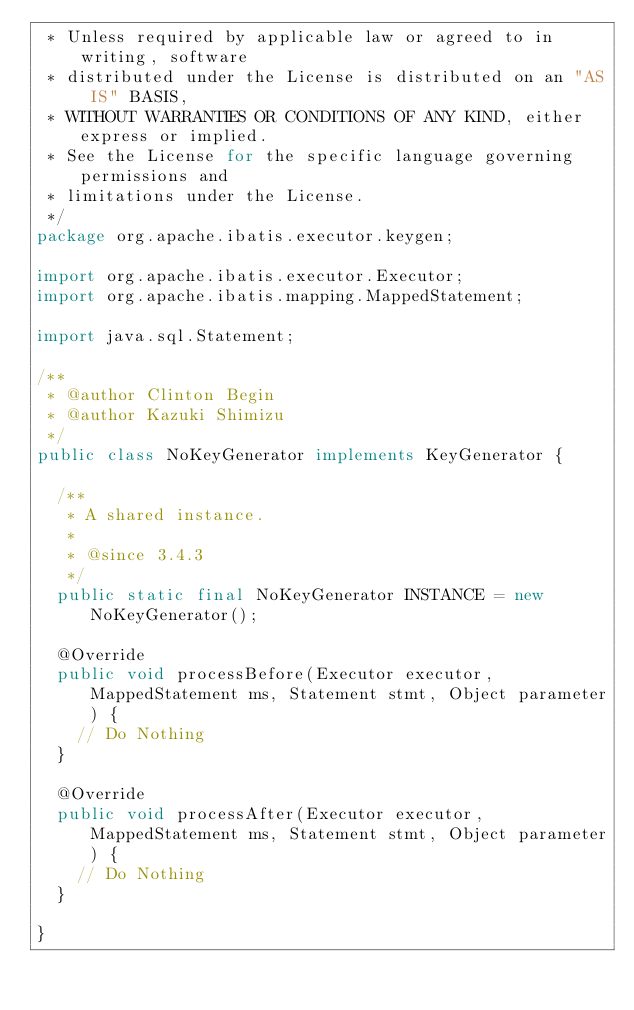<code> <loc_0><loc_0><loc_500><loc_500><_Java_> * Unless required by applicable law or agreed to in writing, software
 * distributed under the License is distributed on an "AS IS" BASIS,
 * WITHOUT WARRANTIES OR CONDITIONS OF ANY KIND, either express or implied.
 * See the License for the specific language governing permissions and
 * limitations under the License.
 */
package org.apache.ibatis.executor.keygen;

import org.apache.ibatis.executor.Executor;
import org.apache.ibatis.mapping.MappedStatement;

import java.sql.Statement;

/**
 * @author Clinton Begin
 * @author Kazuki Shimizu
 */
public class NoKeyGenerator implements KeyGenerator {

  /**
   * A shared instance.
   *
   * @since 3.4.3
   */
  public static final NoKeyGenerator INSTANCE = new NoKeyGenerator();

  @Override
  public void processBefore(Executor executor, MappedStatement ms, Statement stmt, Object parameter) {
    // Do Nothing
  }

  @Override
  public void processAfter(Executor executor, MappedStatement ms, Statement stmt, Object parameter) {
    // Do Nothing
  }

}
</code> 